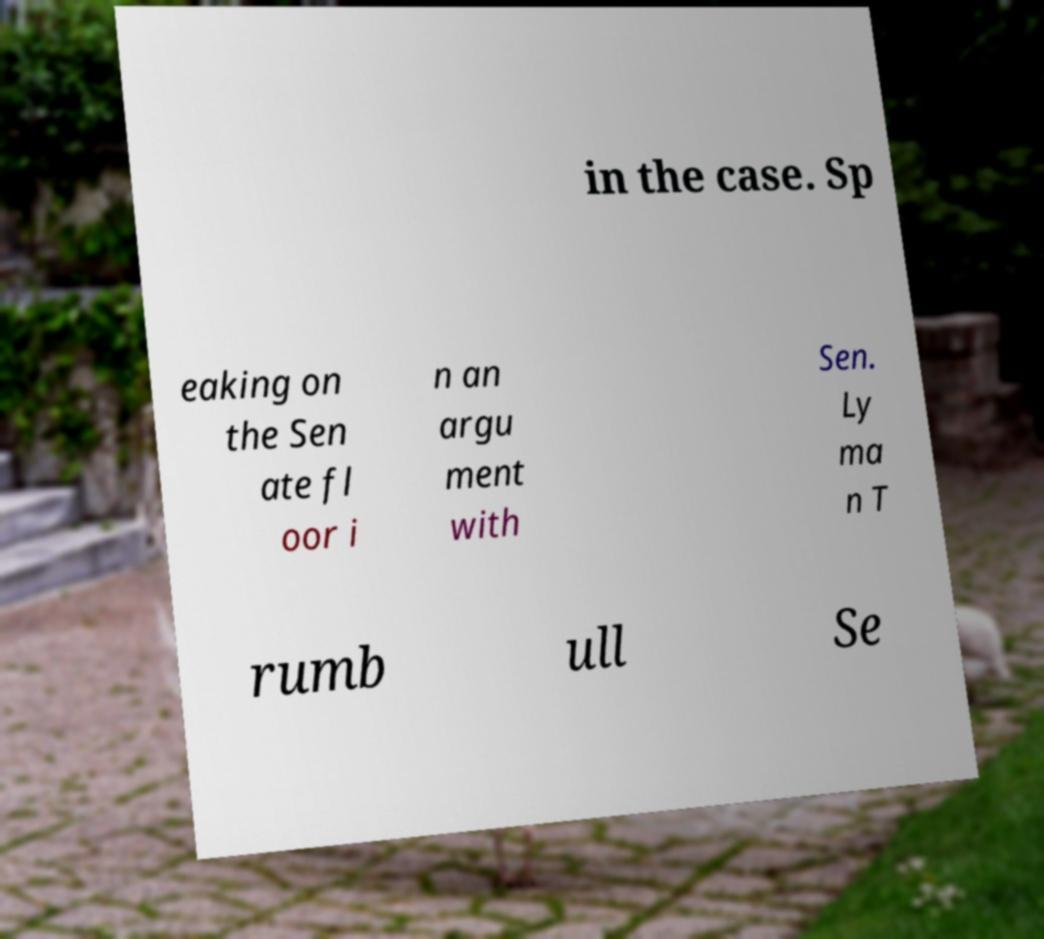Could you assist in decoding the text presented in this image and type it out clearly? in the case. Sp eaking on the Sen ate fl oor i n an argu ment with Sen. Ly ma n T rumb ull Se 